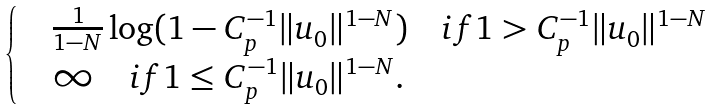<formula> <loc_0><loc_0><loc_500><loc_500>\begin{cases} & \frac { 1 } { 1 - N } \log ( 1 - C _ { p } ^ { - 1 } \| u _ { 0 } \| ^ { 1 - N } ) \quad i f 1 > C _ { p } ^ { - 1 } \| u _ { 0 } \| ^ { 1 - N } \\ & \infty \quad i f 1 \leq C _ { p } ^ { - 1 } \| u _ { 0 } \| ^ { 1 - N } . \end{cases}</formula> 